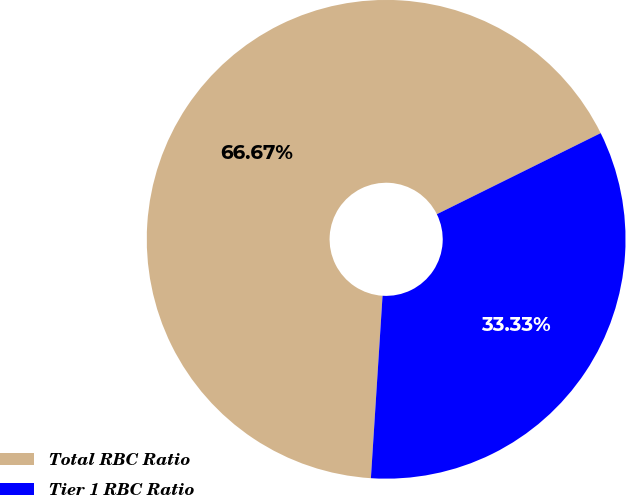Convert chart to OTSL. <chart><loc_0><loc_0><loc_500><loc_500><pie_chart><fcel>Total RBC Ratio<fcel>Tier 1 RBC Ratio<nl><fcel>66.67%<fcel>33.33%<nl></chart> 